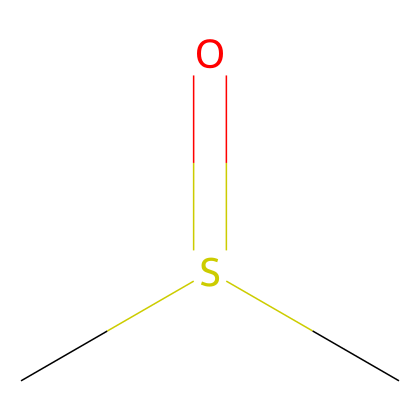What is the name of this compound? The SMILES representation indicates the compound is dimethyl sulfoxide, which is derived from its structure where two methyl groups attach to a sulfur atom with a double bond to an oxygen (sulfoxide functional group).
Answer: dimethyl sulfoxide How many carbon atoms are in this molecule? By analyzing the SMILES representation, CS(=O)C has two methyl groups (C), implying there are two carbon atoms in total in the chemical structure of dimethyl sulfoxide.
Answer: 2 What is the functional group present in this compound? The SMILES shows a sulfur atom (S) bonded to an oxygen atom (O) with a double bond (indicated by '=') and also connected to two carbon atoms (methyl groups). This configuration represents the sulfoxide functional group.
Answer: sulfoxide What type of bond is present between sulfur and oxygen in this compound? In the SMILES notation, the bond between S and O is represented by "S(=O)", which indicates a double bond between sulfur and oxygen. Therefore, this compound features a double bond.
Answer: double bond What is the oxidation state of sulfur in this compound? The sulfur atom in dimethyl sulfoxide is bonded to two carbon atoms and has a double bond to oxygen. The typical oxidation state for sulfur in this state of bonding and with its assigned valency leads to a +4 oxidation state for sulfur in sulfoxide.
Answer: +4 Is this compound polar or non-polar? Dimethyl sulfoxide has a polar functional group (sulfoxide) compared to the relatively non-polar carbon chains present in its structure. With the uneven distribution of charge due to the oxygen, which is more electronegative than sulfur, the compound is categorically classified as polar.
Answer: polar 